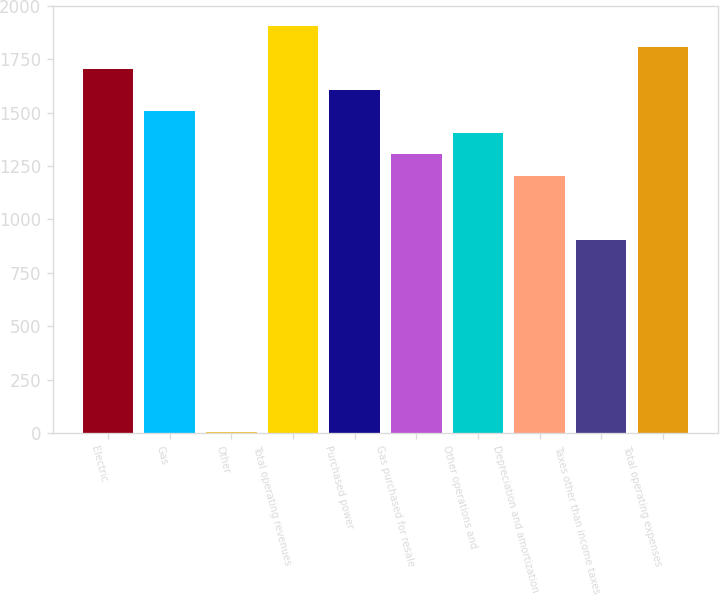Convert chart to OTSL. <chart><loc_0><loc_0><loc_500><loc_500><bar_chart><fcel>Electric<fcel>Gas<fcel>Other<fcel>Total operating revenues<fcel>Purchased power<fcel>Gas purchased for resale<fcel>Other operations and<fcel>Depreciation and amortization<fcel>Taxes other than income taxes<fcel>Total operating expenses<nl><fcel>1706.4<fcel>1506<fcel>3<fcel>1906.8<fcel>1606.2<fcel>1305.6<fcel>1405.8<fcel>1205.4<fcel>904.8<fcel>1806.6<nl></chart> 